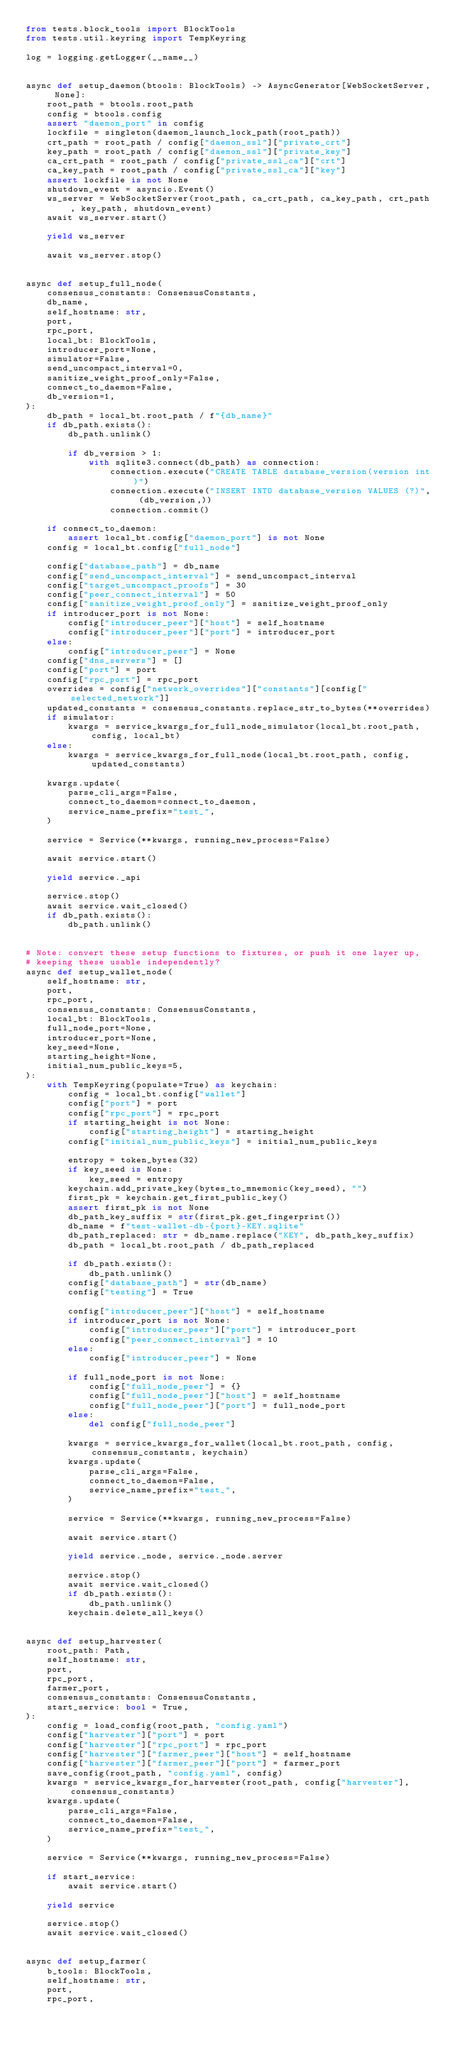Convert code to text. <code><loc_0><loc_0><loc_500><loc_500><_Python_>from tests.block_tools import BlockTools
from tests.util.keyring import TempKeyring

log = logging.getLogger(__name__)


async def setup_daemon(btools: BlockTools) -> AsyncGenerator[WebSocketServer, None]:
    root_path = btools.root_path
    config = btools.config
    assert "daemon_port" in config
    lockfile = singleton(daemon_launch_lock_path(root_path))
    crt_path = root_path / config["daemon_ssl"]["private_crt"]
    key_path = root_path / config["daemon_ssl"]["private_key"]
    ca_crt_path = root_path / config["private_ssl_ca"]["crt"]
    ca_key_path = root_path / config["private_ssl_ca"]["key"]
    assert lockfile is not None
    shutdown_event = asyncio.Event()
    ws_server = WebSocketServer(root_path, ca_crt_path, ca_key_path, crt_path, key_path, shutdown_event)
    await ws_server.start()

    yield ws_server

    await ws_server.stop()


async def setup_full_node(
    consensus_constants: ConsensusConstants,
    db_name,
    self_hostname: str,
    port,
    rpc_port,
    local_bt: BlockTools,
    introducer_port=None,
    simulator=False,
    send_uncompact_interval=0,
    sanitize_weight_proof_only=False,
    connect_to_daemon=False,
    db_version=1,
):
    db_path = local_bt.root_path / f"{db_name}"
    if db_path.exists():
        db_path.unlink()

        if db_version > 1:
            with sqlite3.connect(db_path) as connection:
                connection.execute("CREATE TABLE database_version(version int)")
                connection.execute("INSERT INTO database_version VALUES (?)", (db_version,))
                connection.commit()

    if connect_to_daemon:
        assert local_bt.config["daemon_port"] is not None
    config = local_bt.config["full_node"]

    config["database_path"] = db_name
    config["send_uncompact_interval"] = send_uncompact_interval
    config["target_uncompact_proofs"] = 30
    config["peer_connect_interval"] = 50
    config["sanitize_weight_proof_only"] = sanitize_weight_proof_only
    if introducer_port is not None:
        config["introducer_peer"]["host"] = self_hostname
        config["introducer_peer"]["port"] = introducer_port
    else:
        config["introducer_peer"] = None
    config["dns_servers"] = []
    config["port"] = port
    config["rpc_port"] = rpc_port
    overrides = config["network_overrides"]["constants"][config["selected_network"]]
    updated_constants = consensus_constants.replace_str_to_bytes(**overrides)
    if simulator:
        kwargs = service_kwargs_for_full_node_simulator(local_bt.root_path, config, local_bt)
    else:
        kwargs = service_kwargs_for_full_node(local_bt.root_path, config, updated_constants)

    kwargs.update(
        parse_cli_args=False,
        connect_to_daemon=connect_to_daemon,
        service_name_prefix="test_",
    )

    service = Service(**kwargs, running_new_process=False)

    await service.start()

    yield service._api

    service.stop()
    await service.wait_closed()
    if db_path.exists():
        db_path.unlink()


# Note: convert these setup functions to fixtures, or push it one layer up,
# keeping these usable independently?
async def setup_wallet_node(
    self_hostname: str,
    port,
    rpc_port,
    consensus_constants: ConsensusConstants,
    local_bt: BlockTools,
    full_node_port=None,
    introducer_port=None,
    key_seed=None,
    starting_height=None,
    initial_num_public_keys=5,
):
    with TempKeyring(populate=True) as keychain:
        config = local_bt.config["wallet"]
        config["port"] = port
        config["rpc_port"] = rpc_port
        if starting_height is not None:
            config["starting_height"] = starting_height
        config["initial_num_public_keys"] = initial_num_public_keys

        entropy = token_bytes(32)
        if key_seed is None:
            key_seed = entropy
        keychain.add_private_key(bytes_to_mnemonic(key_seed), "")
        first_pk = keychain.get_first_public_key()
        assert first_pk is not None
        db_path_key_suffix = str(first_pk.get_fingerprint())
        db_name = f"test-wallet-db-{port}-KEY.sqlite"
        db_path_replaced: str = db_name.replace("KEY", db_path_key_suffix)
        db_path = local_bt.root_path / db_path_replaced

        if db_path.exists():
            db_path.unlink()
        config["database_path"] = str(db_name)
        config["testing"] = True

        config["introducer_peer"]["host"] = self_hostname
        if introducer_port is not None:
            config["introducer_peer"]["port"] = introducer_port
            config["peer_connect_interval"] = 10
        else:
            config["introducer_peer"] = None

        if full_node_port is not None:
            config["full_node_peer"] = {}
            config["full_node_peer"]["host"] = self_hostname
            config["full_node_peer"]["port"] = full_node_port
        else:
            del config["full_node_peer"]

        kwargs = service_kwargs_for_wallet(local_bt.root_path, config, consensus_constants, keychain)
        kwargs.update(
            parse_cli_args=False,
            connect_to_daemon=False,
            service_name_prefix="test_",
        )

        service = Service(**kwargs, running_new_process=False)

        await service.start()

        yield service._node, service._node.server

        service.stop()
        await service.wait_closed()
        if db_path.exists():
            db_path.unlink()
        keychain.delete_all_keys()


async def setup_harvester(
    root_path: Path,
    self_hostname: str,
    port,
    rpc_port,
    farmer_port,
    consensus_constants: ConsensusConstants,
    start_service: bool = True,
):
    config = load_config(root_path, "config.yaml")
    config["harvester"]["port"] = port
    config["harvester"]["rpc_port"] = rpc_port
    config["harvester"]["farmer_peer"]["host"] = self_hostname
    config["harvester"]["farmer_peer"]["port"] = farmer_port
    save_config(root_path, "config.yaml", config)
    kwargs = service_kwargs_for_harvester(root_path, config["harvester"], consensus_constants)
    kwargs.update(
        parse_cli_args=False,
        connect_to_daemon=False,
        service_name_prefix="test_",
    )

    service = Service(**kwargs, running_new_process=False)

    if start_service:
        await service.start()

    yield service

    service.stop()
    await service.wait_closed()


async def setup_farmer(
    b_tools: BlockTools,
    self_hostname: str,
    port,
    rpc_port,</code> 